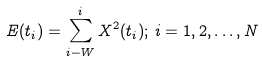Convert formula to latex. <formula><loc_0><loc_0><loc_500><loc_500>E ( t _ { i } ) = \sum _ { i - W } ^ { i } X ^ { 2 } ( t _ { i } ) ; \, i = 1 , 2 , \dots , N</formula> 